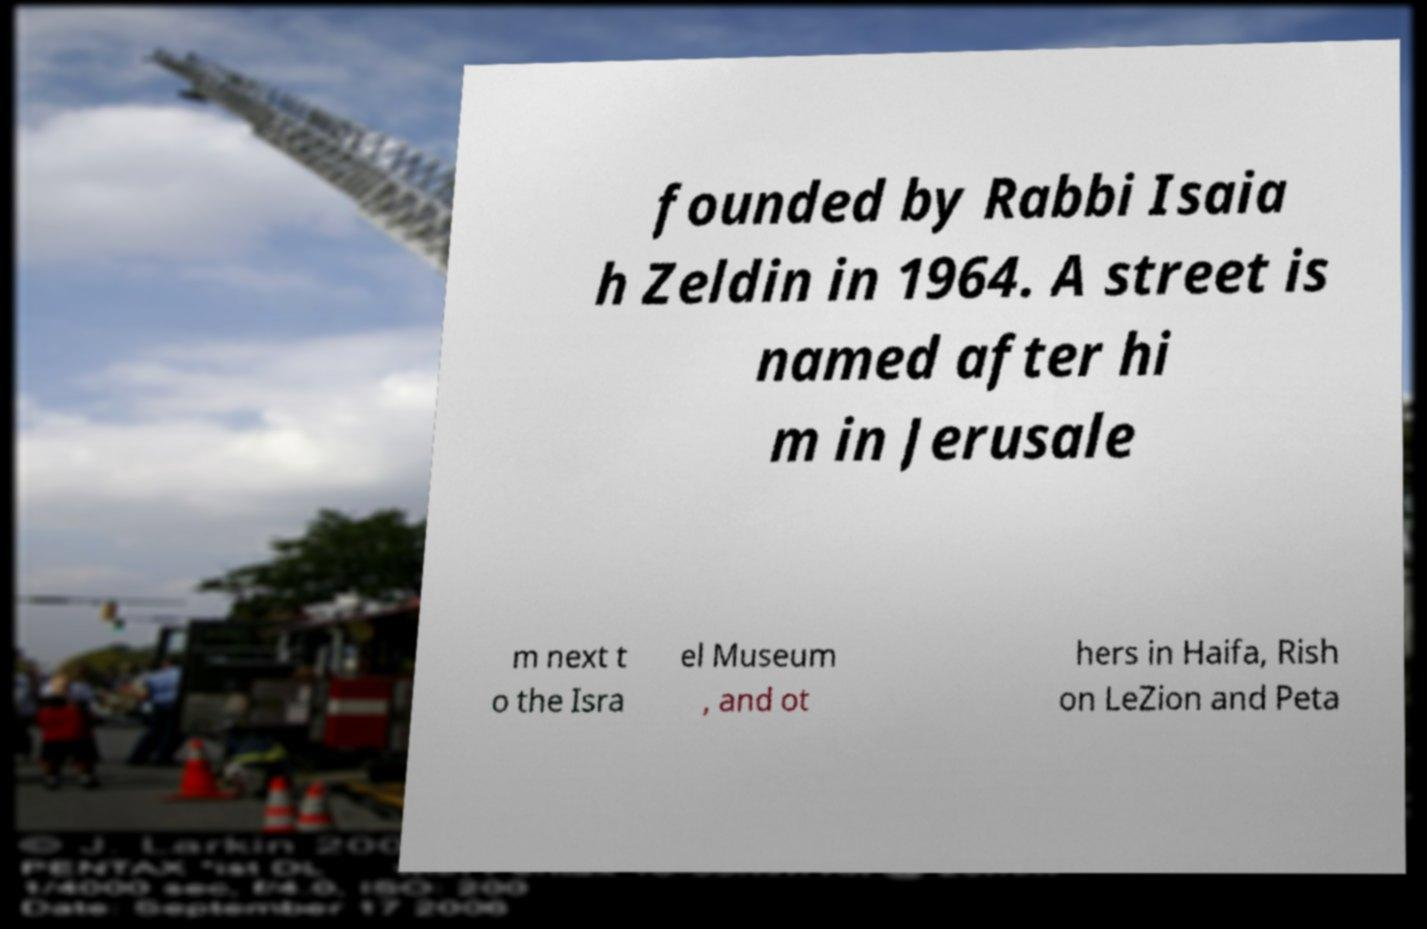Please read and relay the text visible in this image. What does it say? founded by Rabbi Isaia h Zeldin in 1964. A street is named after hi m in Jerusale m next t o the Isra el Museum , and ot hers in Haifa, Rish on LeZion and Peta 